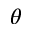<formula> <loc_0><loc_0><loc_500><loc_500>\theta</formula> 